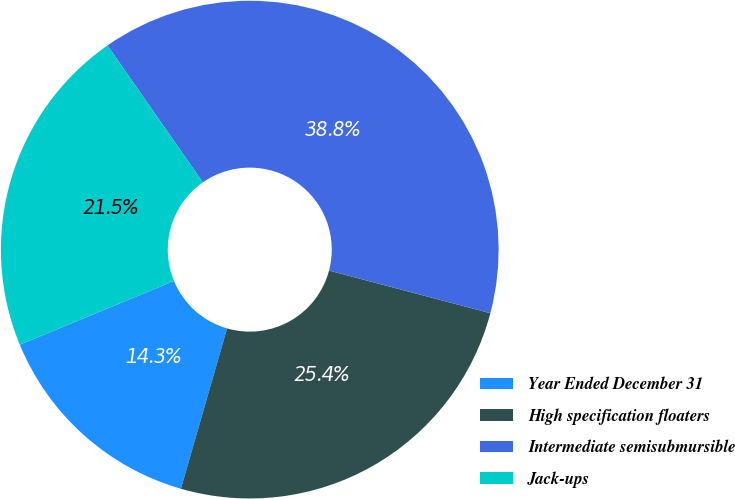Convert chart to OTSL. <chart><loc_0><loc_0><loc_500><loc_500><pie_chart><fcel>Year Ended December 31<fcel>High specification floaters<fcel>Intermediate semisubmursible<fcel>Jack-ups<nl><fcel>14.3%<fcel>25.35%<fcel>38.8%<fcel>21.55%<nl></chart> 